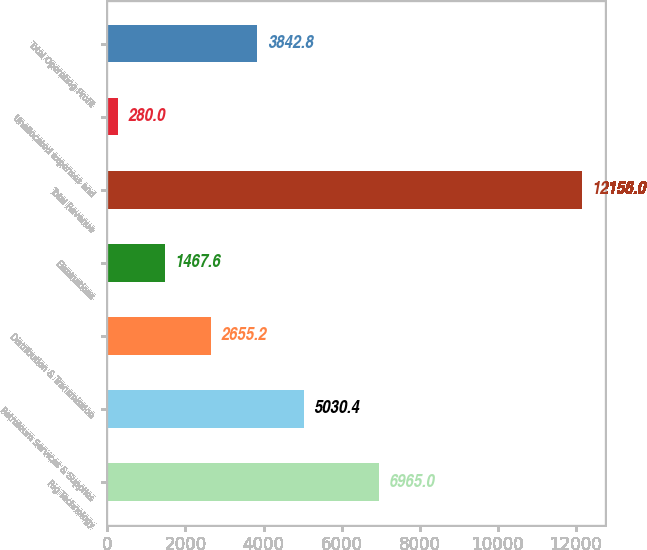<chart> <loc_0><loc_0><loc_500><loc_500><bar_chart><fcel>Rig Technology<fcel>Petroleum Services & Supplies<fcel>Distribution & Transmission<fcel>Eliminations<fcel>Total Revenue<fcel>Unallocated expenses and<fcel>Total Operating Profit<nl><fcel>6965<fcel>5030.4<fcel>2655.2<fcel>1467.6<fcel>12156<fcel>280<fcel>3842.8<nl></chart> 